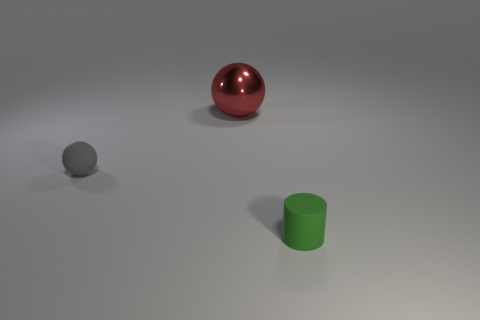Subtract all red cylinders. Subtract all red spheres. How many cylinders are left? 1 Add 2 tiny purple matte things. How many objects exist? 5 Subtract all balls. How many objects are left? 1 Subtract all gray metal things. Subtract all cylinders. How many objects are left? 2 Add 2 green things. How many green things are left? 3 Add 1 large metallic things. How many large metallic things exist? 2 Subtract 0 cyan cylinders. How many objects are left? 3 